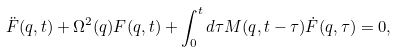Convert formula to latex. <formula><loc_0><loc_0><loc_500><loc_500>\ddot { F } ( q , t ) + \Omega ^ { 2 } ( q ) F ( q , t ) + \int _ { 0 } ^ { t } d \tau M ( q , t - \tau ) \dot { F } ( q , \tau ) = 0 ,</formula> 